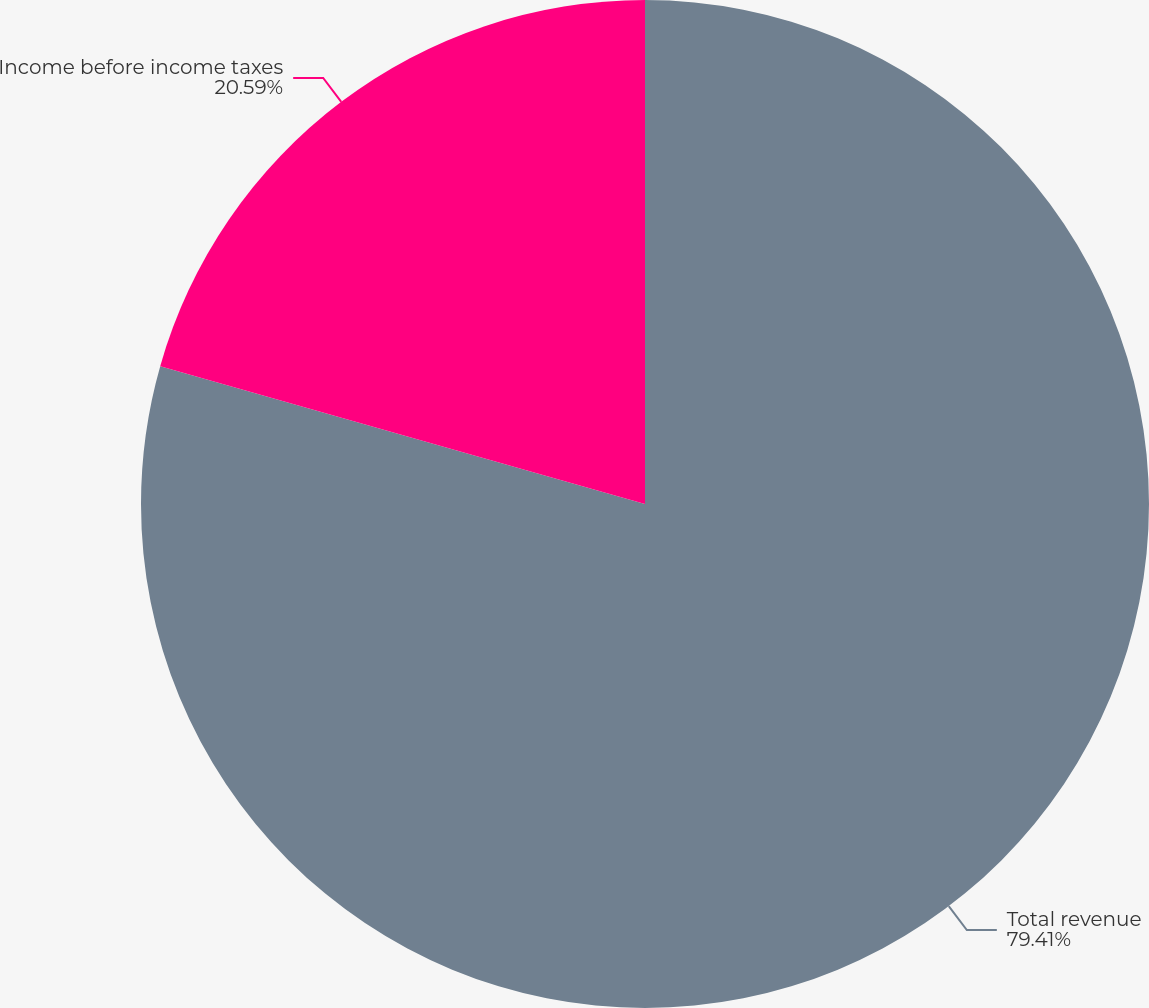Convert chart to OTSL. <chart><loc_0><loc_0><loc_500><loc_500><pie_chart><fcel>Total revenue<fcel>Income before income taxes<nl><fcel>79.41%<fcel>20.59%<nl></chart> 